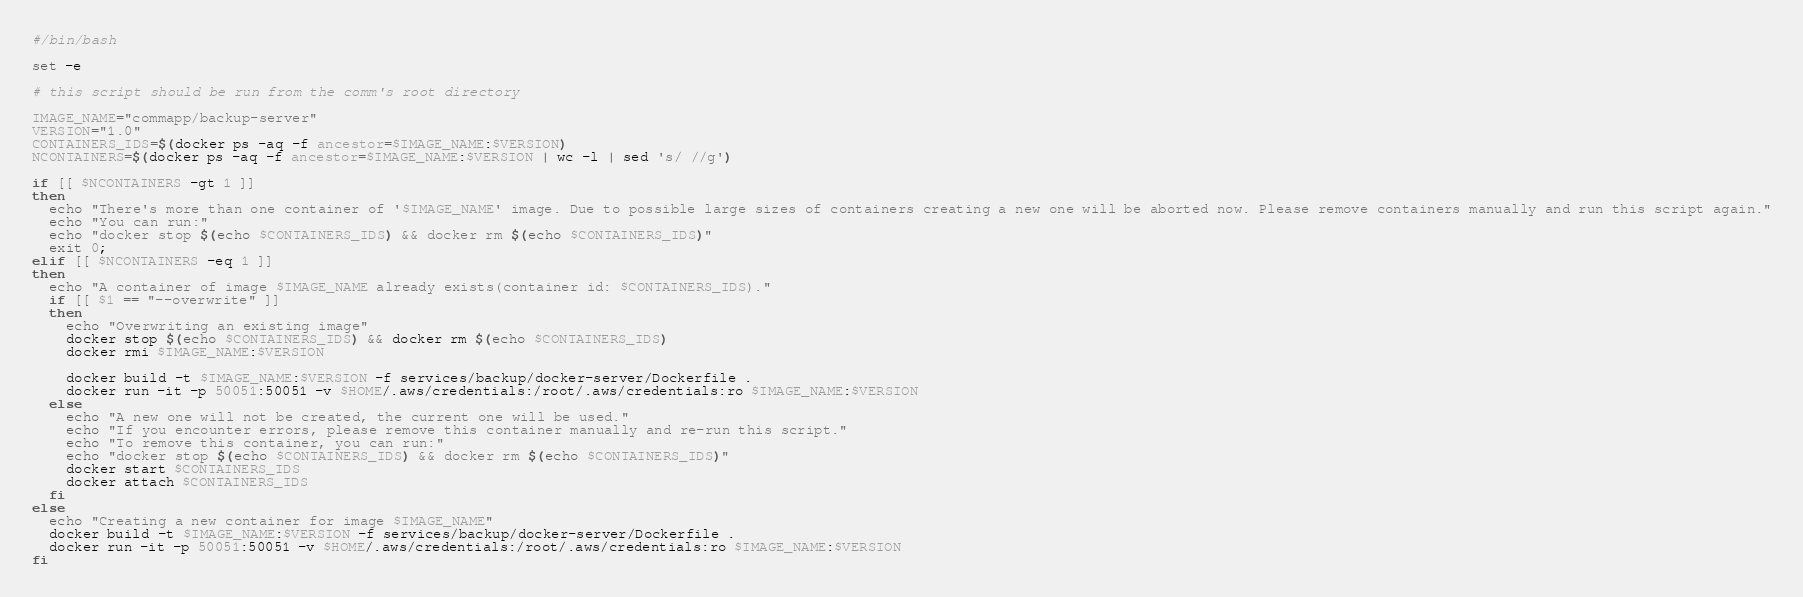<code> <loc_0><loc_0><loc_500><loc_500><_Bash_>#/bin/bash

set -e

# this script should be run from the comm's root directory

IMAGE_NAME="commapp/backup-server"
VERSION="1.0"
CONTAINERS_IDS=$(docker ps -aq -f ancestor=$IMAGE_NAME:$VERSION)
NCONTAINERS=$(docker ps -aq -f ancestor=$IMAGE_NAME:$VERSION | wc -l | sed 's/ //g')

if [[ $NCONTAINERS -gt 1 ]]
then
  echo "There's more than one container of '$IMAGE_NAME' image. Due to possible large sizes of containers creating a new one will be aborted now. Please remove containers manually and run this script again."
  echo "You can run:"
  echo "docker stop $(echo $CONTAINERS_IDS) && docker rm $(echo $CONTAINERS_IDS)"
  exit 0;
elif [[ $NCONTAINERS -eq 1 ]]
then
  echo "A container of image $IMAGE_NAME already exists(container id: $CONTAINERS_IDS)."
  if [[ $1 == "--overwrite" ]]
  then
    echo "Overwriting an existing image"
    docker stop $(echo $CONTAINERS_IDS) && docker rm $(echo $CONTAINERS_IDS)
    docker rmi $IMAGE_NAME:$VERSION

    docker build -t $IMAGE_NAME:$VERSION -f services/backup/docker-server/Dockerfile .
    docker run -it -p 50051:50051 -v $HOME/.aws/credentials:/root/.aws/credentials:ro $IMAGE_NAME:$VERSION
  else
    echo "A new one will not be created, the current one will be used."
    echo "If you encounter errors, please remove this container manually and re-run this script."
    echo "To remove this container, you can run:"
    echo "docker stop $(echo $CONTAINERS_IDS) && docker rm $(echo $CONTAINERS_IDS)"
    docker start $CONTAINERS_IDS
    docker attach $CONTAINERS_IDS
  fi
else
  echo "Creating a new container for image $IMAGE_NAME"
  docker build -t $IMAGE_NAME:$VERSION -f services/backup/docker-server/Dockerfile .
  docker run -it -p 50051:50051 -v $HOME/.aws/credentials:/root/.aws/credentials:ro $IMAGE_NAME:$VERSION
fi
</code> 